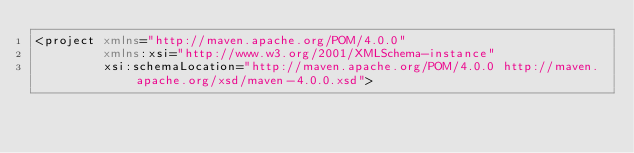Convert code to text. <code><loc_0><loc_0><loc_500><loc_500><_XML_><project xmlns="http://maven.apache.org/POM/4.0.0"
         xmlns:xsi="http://www.w3.org/2001/XMLSchema-instance"
         xsi:schemaLocation="http://maven.apache.org/POM/4.0.0 http://maven.apache.org/xsd/maven-4.0.0.xsd"></code> 